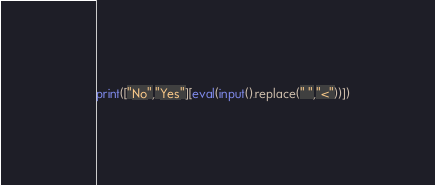<code> <loc_0><loc_0><loc_500><loc_500><_Python_>print(["No","Yes"][eval(input().replace(" ","<"))])
</code> 